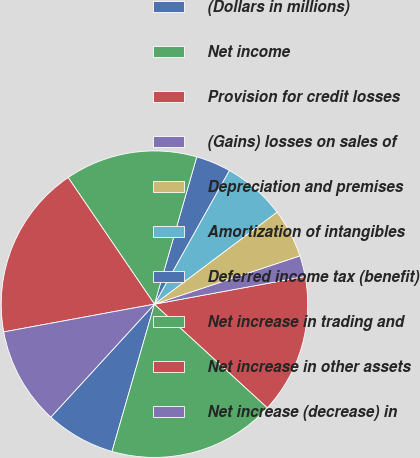Convert chart to OTSL. <chart><loc_0><loc_0><loc_500><loc_500><pie_chart><fcel>(Dollars in millions)<fcel>Net income<fcel>Provision for credit losses<fcel>(Gains) losses on sales of<fcel>Depreciation and premises<fcel>Amortization of intangibles<fcel>Deferred income tax (benefit)<fcel>Net increase in trading and<fcel>Net increase in other assets<fcel>Net increase (decrease) in<nl><fcel>7.35%<fcel>17.65%<fcel>14.71%<fcel>2.21%<fcel>5.15%<fcel>6.62%<fcel>3.68%<fcel>13.97%<fcel>18.38%<fcel>10.29%<nl></chart> 